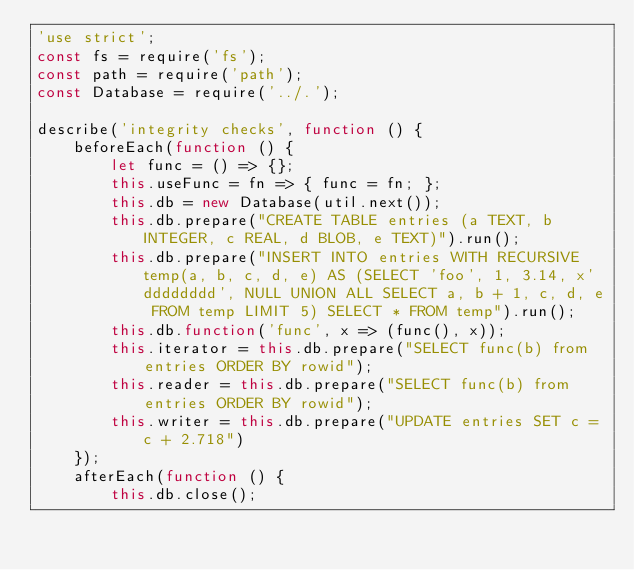Convert code to text. <code><loc_0><loc_0><loc_500><loc_500><_JavaScript_>'use strict';
const fs = require('fs');
const path = require('path');
const Database = require('../.');

describe('integrity checks', function () {
	beforeEach(function () {
		let func = () => {};
		this.useFunc = fn => { func = fn; };
		this.db = new Database(util.next());
		this.db.prepare("CREATE TABLE entries (a TEXT, b INTEGER, c REAL, d BLOB, e TEXT)").run();
		this.db.prepare("INSERT INTO entries WITH RECURSIVE temp(a, b, c, d, e) AS (SELECT 'foo', 1, 3.14, x'dddddddd', NULL UNION ALL SELECT a, b + 1, c, d, e FROM temp LIMIT 5) SELECT * FROM temp").run();
		this.db.function('func', x => (func(), x));
		this.iterator = this.db.prepare("SELECT func(b) from entries ORDER BY rowid");
		this.reader = this.db.prepare("SELECT func(b) from entries ORDER BY rowid");
		this.writer = this.db.prepare("UPDATE entries SET c = c + 2.718")
	});
	afterEach(function () {
		this.db.close();</code> 